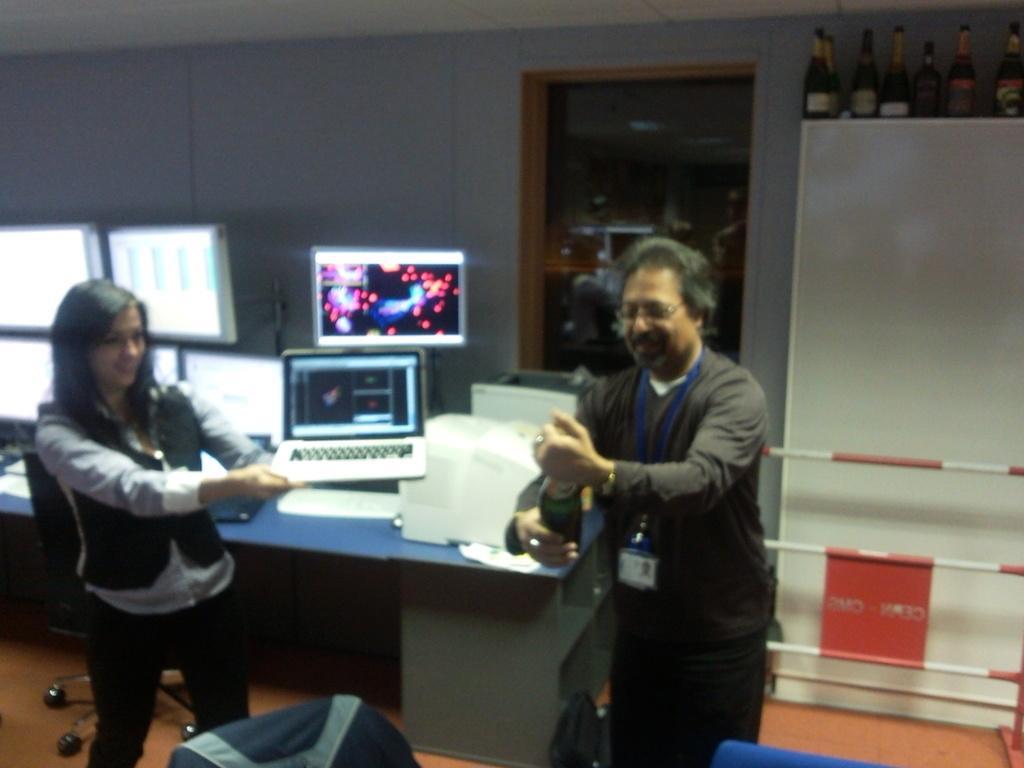Can you describe this image briefly? In this picture there are two people , one of them is holding a glass bottle in his hand and the other is holding a laptop. We observe many monitors placed on top of the table and there is a glass window in the background. There are also glass bottles kept on to of a white container. 